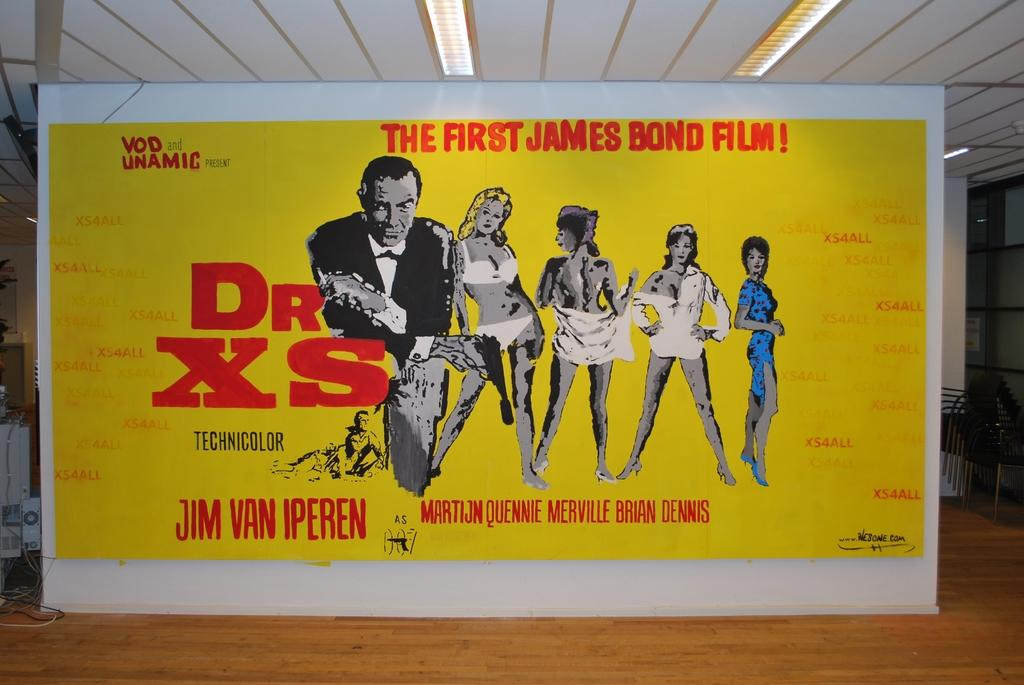Provide a one-sentence caption for the provided image. A poster for a film called Dr XS the first james bond film. 